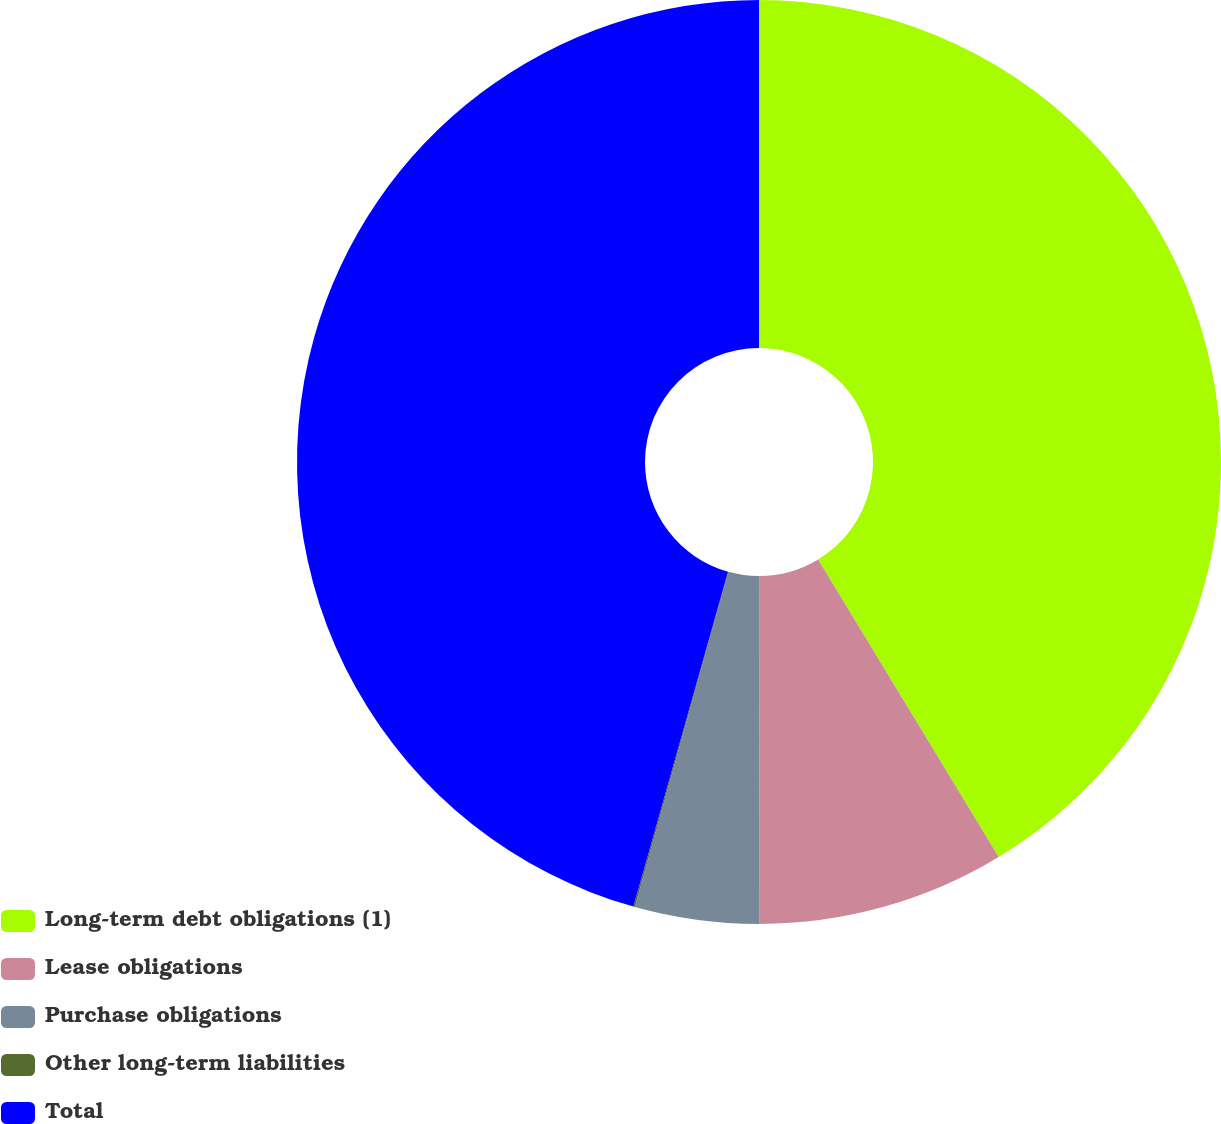Convert chart. <chart><loc_0><loc_0><loc_500><loc_500><pie_chart><fcel>Long-term debt obligations (1)<fcel>Lease obligations<fcel>Purchase obligations<fcel>Other long-term liabilities<fcel>Total<nl><fcel>41.32%<fcel>8.66%<fcel>4.35%<fcel>0.05%<fcel>45.62%<nl></chart> 